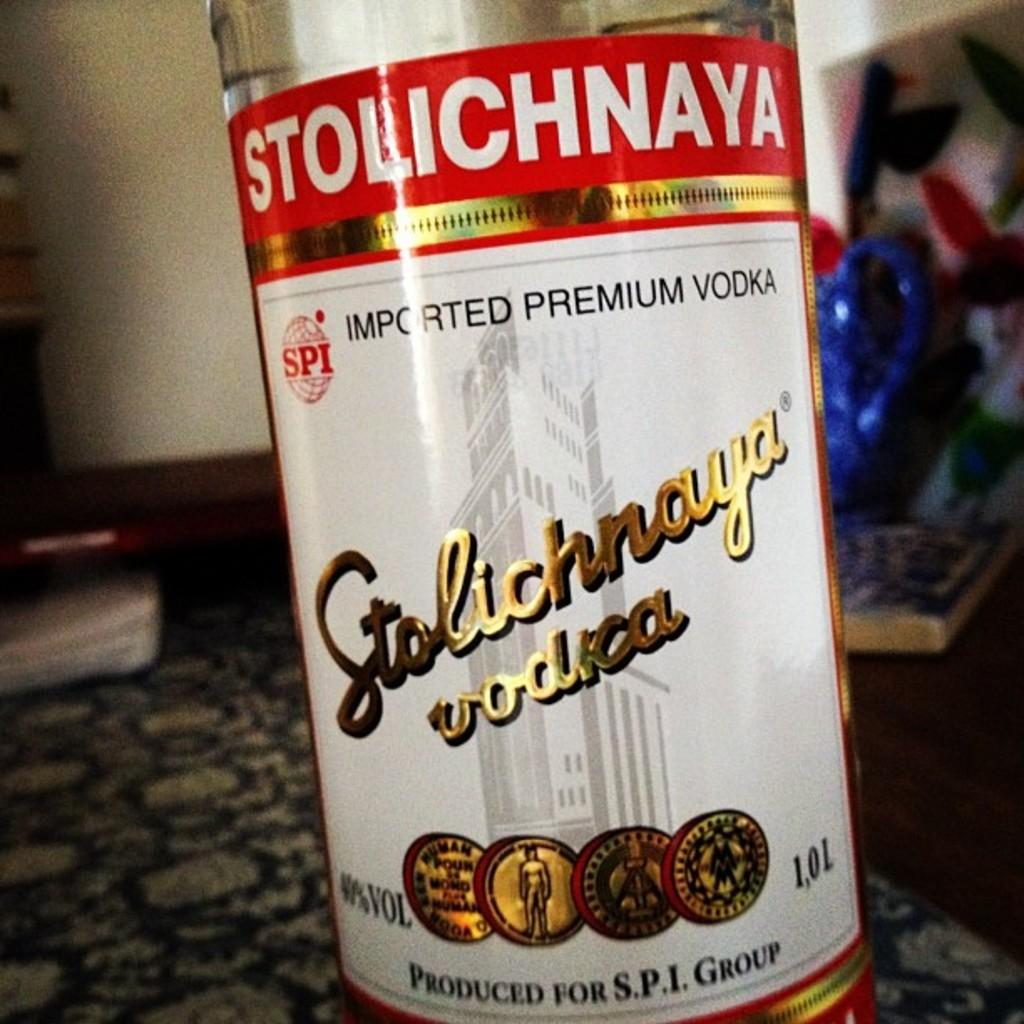What is the main object in the image? There is a wine bottle in the image. What is on the wine bottle? A sticker is attached to the wine bottle. What colors are present on the sticker? The sticker has white, red, and gold colors. What can be seen in the background of the image? There are objects visible on the floor in the background of the image. What type of jeans is the person wearing in the image? There is no person visible in the image, so it is not possible to determine what type of jeans they might be wearing. 